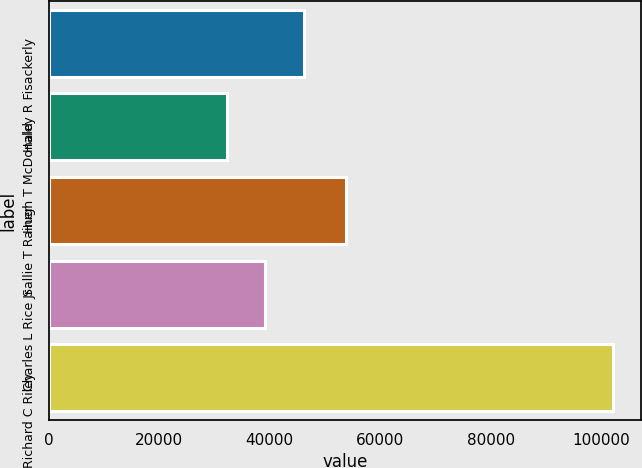<chart> <loc_0><loc_0><loc_500><loc_500><bar_chart><fcel>Haley R Fisackerly<fcel>Hugh T McDonald<fcel>Sallie T Rainer<fcel>Charles L Rice Jr<fcel>Richard C Riley<nl><fcel>46169.6<fcel>32184<fcel>53797<fcel>39176.8<fcel>102112<nl></chart> 